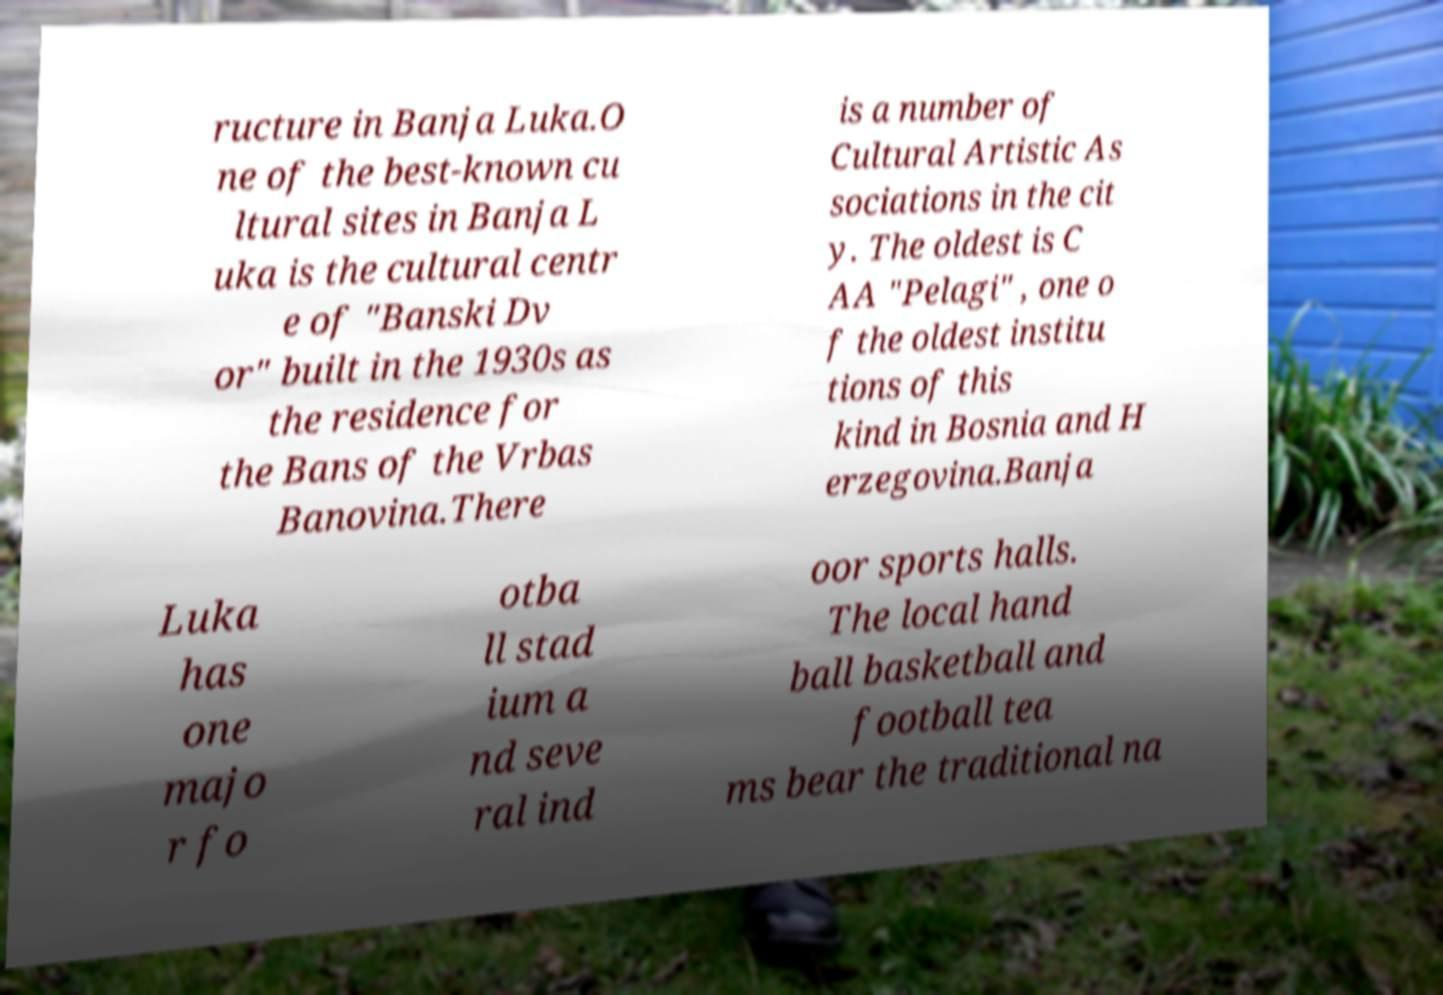I need the written content from this picture converted into text. Can you do that? ructure in Banja Luka.O ne of the best-known cu ltural sites in Banja L uka is the cultural centr e of "Banski Dv or" built in the 1930s as the residence for the Bans of the Vrbas Banovina.There is a number of Cultural Artistic As sociations in the cit y. The oldest is C AA "Pelagi" , one o f the oldest institu tions of this kind in Bosnia and H erzegovina.Banja Luka has one majo r fo otba ll stad ium a nd seve ral ind oor sports halls. The local hand ball basketball and football tea ms bear the traditional na 